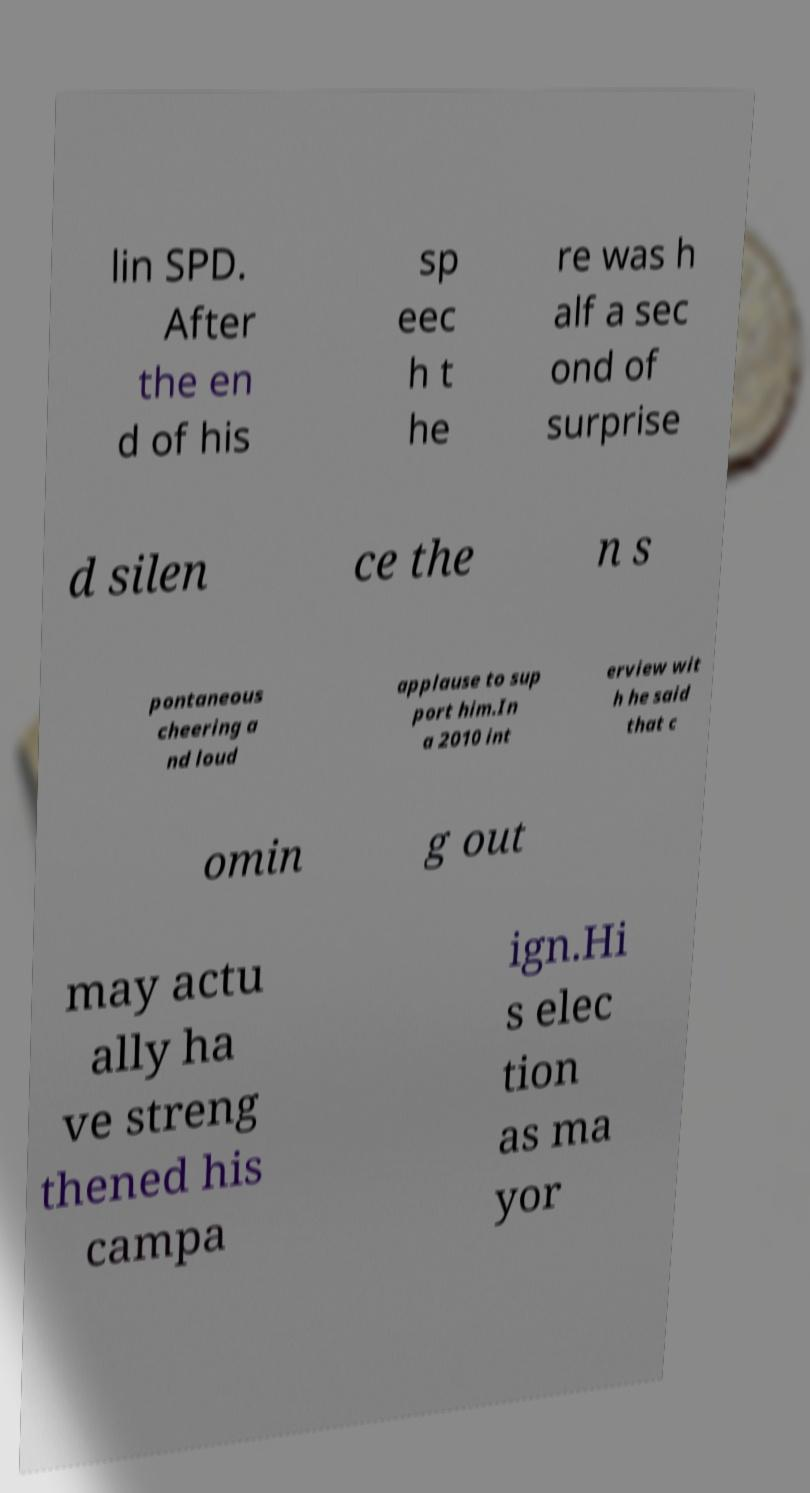Can you accurately transcribe the text from the provided image for me? lin SPD. After the en d of his sp eec h t he re was h alf a sec ond of surprise d silen ce the n s pontaneous cheering a nd loud applause to sup port him.In a 2010 int erview wit h he said that c omin g out may actu ally ha ve streng thened his campa ign.Hi s elec tion as ma yor 